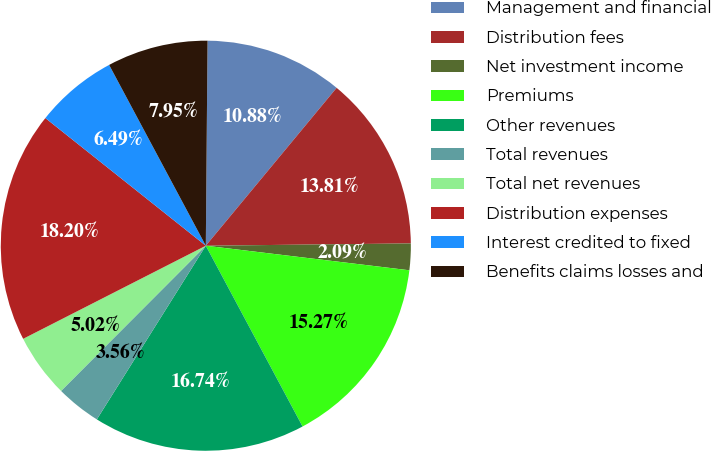Convert chart. <chart><loc_0><loc_0><loc_500><loc_500><pie_chart><fcel>Management and financial<fcel>Distribution fees<fcel>Net investment income<fcel>Premiums<fcel>Other revenues<fcel>Total revenues<fcel>Total net revenues<fcel>Distribution expenses<fcel>Interest credited to fixed<fcel>Benefits claims losses and<nl><fcel>10.88%<fcel>13.81%<fcel>2.09%<fcel>15.27%<fcel>16.74%<fcel>3.56%<fcel>5.02%<fcel>18.2%<fcel>6.49%<fcel>7.95%<nl></chart> 